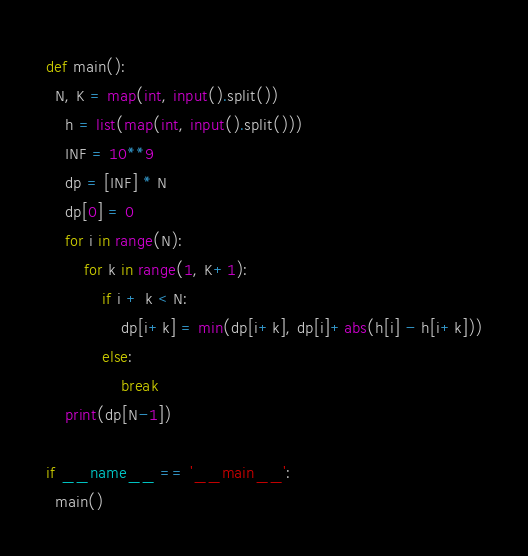Convert code to text. <code><loc_0><loc_0><loc_500><loc_500><_Python_>def main():
  N, K = map(int, input().split())
	h = list(map(int, input().split()))
	INF = 10**9
	dp = [INF] * N
	dp[0] = 0
	for i in range(N):
    	for k in range(1, K+1):
        	if i + k < N:
            	dp[i+k] = min(dp[i+k], dp[i]+abs(h[i] - h[i+k]))
        	else:
            	break
	print(dp[N-1])

if __name__ == '__main__':
  main()</code> 